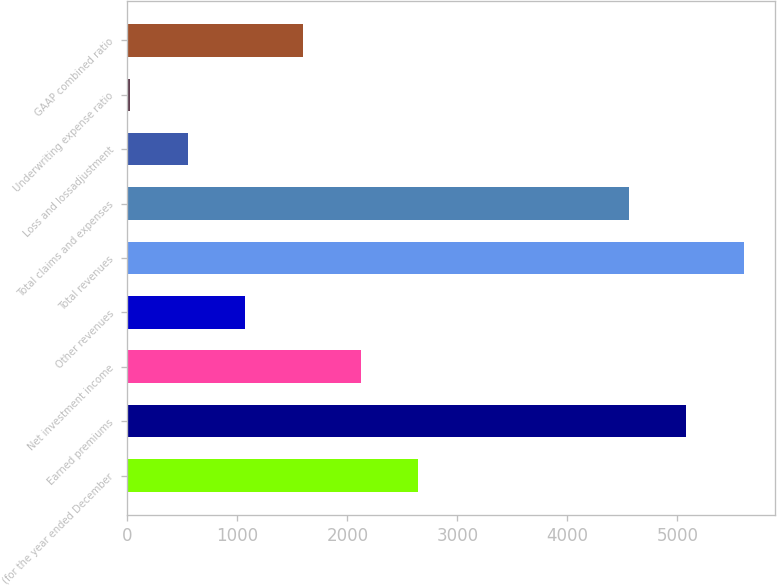<chart> <loc_0><loc_0><loc_500><loc_500><bar_chart><fcel>(for the year ended December<fcel>Earned premiums<fcel>Net investment income<fcel>Other revenues<fcel>Total revenues<fcel>Total claims and expenses<fcel>Loss and lossadjustment<fcel>Underwriting expense ratio<fcel>GAAP combined ratio<nl><fcel>2645.85<fcel>5079.43<fcel>2121.42<fcel>1072.56<fcel>5603.86<fcel>4555<fcel>548.13<fcel>23.7<fcel>1596.99<nl></chart> 